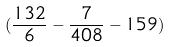<formula> <loc_0><loc_0><loc_500><loc_500>( \frac { 1 3 2 } { 6 } - \frac { 7 } { 4 0 8 } - 1 5 9 )</formula> 